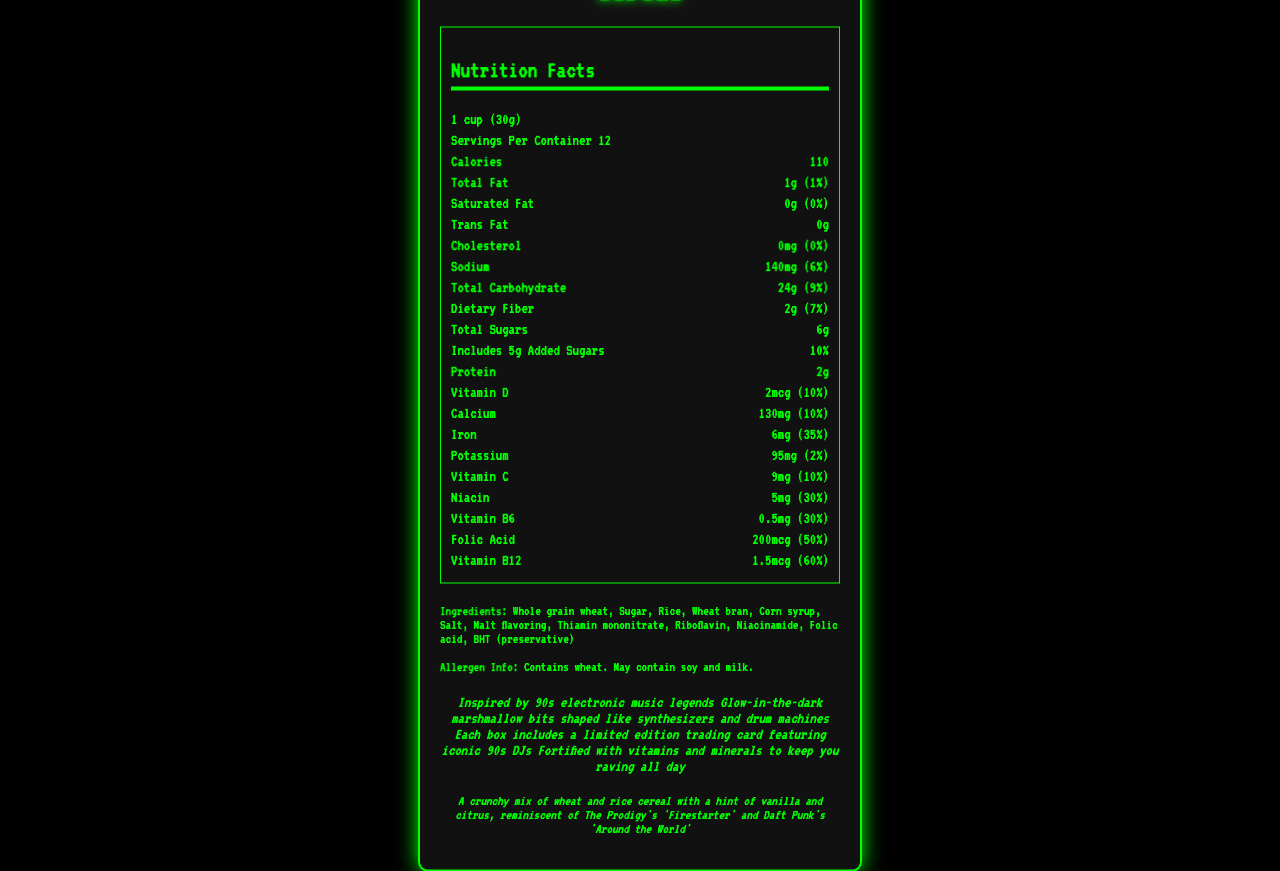what is the serving size of the cereal? The serving size is displayed at the top of the Nutrition Facts section as 1 cup (30g).
Answer: 1 cup (30g) How many servings are there per container? The label indicates there are 12 servings per container.
Answer: 12 How many calories are in one serving? The number of calories per serving is listed as 110 calories.
Answer: 110 How much total fat is in one serving? The total fat amount listed for one serving is 1g.
Answer: 1g What percentage of your daily iron intake does one serving provide? The daily value percentage for iron is provided as 35%.
Answer: 35% What kind of flavor profile does this cereal have? The flavor profile is described towards the bottom of the document.
Answer: A crunchy mix of wheat and rice cereal with a hint of vanilla and citrus, reminiscent of The Prodigy's 'Firestarter' and Daft Punk's 'Around the World' Which of the following ingredients is NOT in the cereal? A. Whole grain wheat B. Corn syrup C. Honey D. Rice The ingredients list includes whole grain wheat, corn syrup, and rice, but honey is not mentioned.
Answer: C. Honey What vitamins are added to this cereal? A. Vitamin A, Vitamin C, Vitamin D B. Vitamin C, Vitamin D, Vitamin B12 C. Vitamin E, Vitamin D, Vitamin B6 The Nutrition Facts section lists Vitamin C (9mg), Vitamin D (2mcg), and Vitamin B12 (1.5mcg).
Answer: B. Vitamin C, Vitamin D, Vitamin B12 Is there any trans fat in the cereal? The trans fat amount is listed as 0g.
Answer: No Please summarize the main features of the Analog Beats Breakfast Cereal. This summary encapsulates the nutrition facts, flavor profile, and unique marketing claims of the cereal.
Answer: The Analog Beats Breakfast Cereal is a limited edition cereal inspired by 90s electronic music artists. It comes in servings of 1 cup (30g) with 12 servings per container, and provides various nutrients such as 2g of protein, 2g of dietary fiber, 6g of total sugars, and is fortified with multiple vitamins and minerals like iron, Vitamin C, and Vitamin D. The cereal contains whole grain wheat, sugar, and rice, and has glow-in-the-dark marshmallow bits shaped like synthesizers and drum machines. Each box includes a limited edition trading card featuring iconic 90s DJs. Which h denotes the product? The given document provides only Nutrition Facts and marketing information about the product, but does not specify any variable denoted by h.
Answer: Not enough information Does the cereal contain soy or milk? The allergen information states: "Contains wheat. May contain soy and milk."
Answer: May contain 